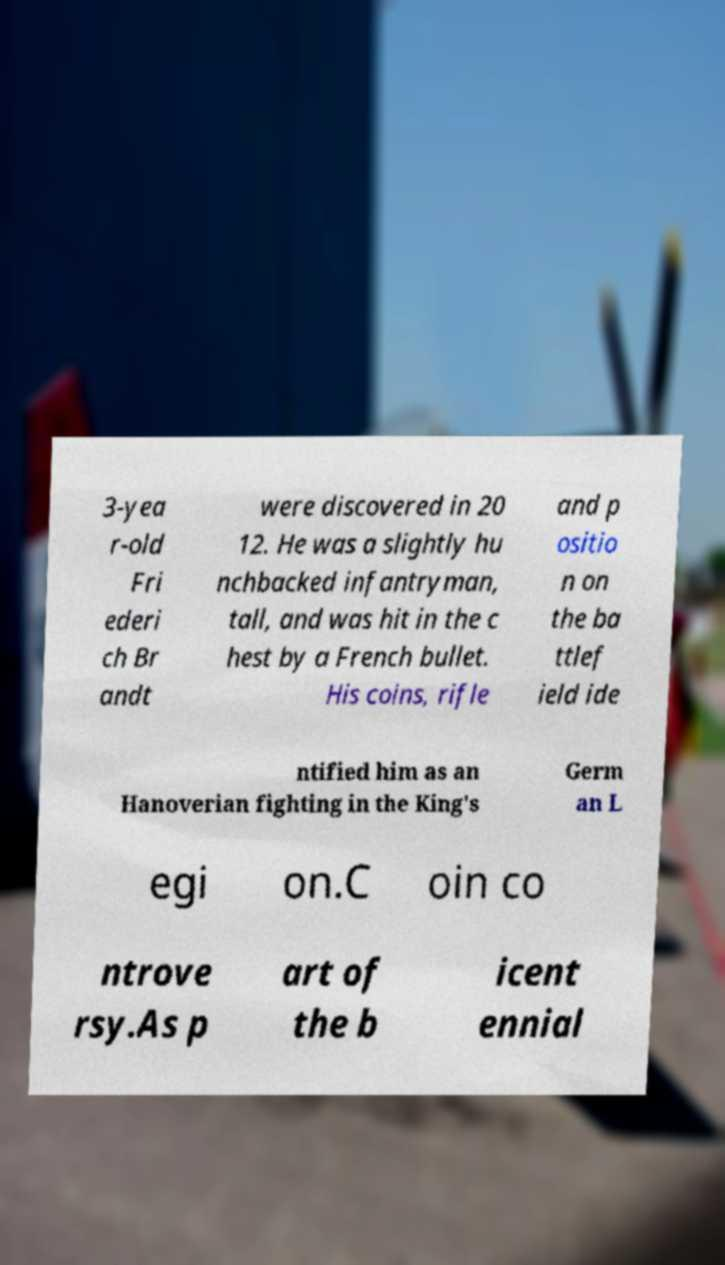Please identify and transcribe the text found in this image. 3-yea r-old Fri ederi ch Br andt were discovered in 20 12. He was a slightly hu nchbacked infantryman, tall, and was hit in the c hest by a French bullet. His coins, rifle and p ositio n on the ba ttlef ield ide ntified him as an Hanoverian fighting in the King's Germ an L egi on.C oin co ntrove rsy.As p art of the b icent ennial 